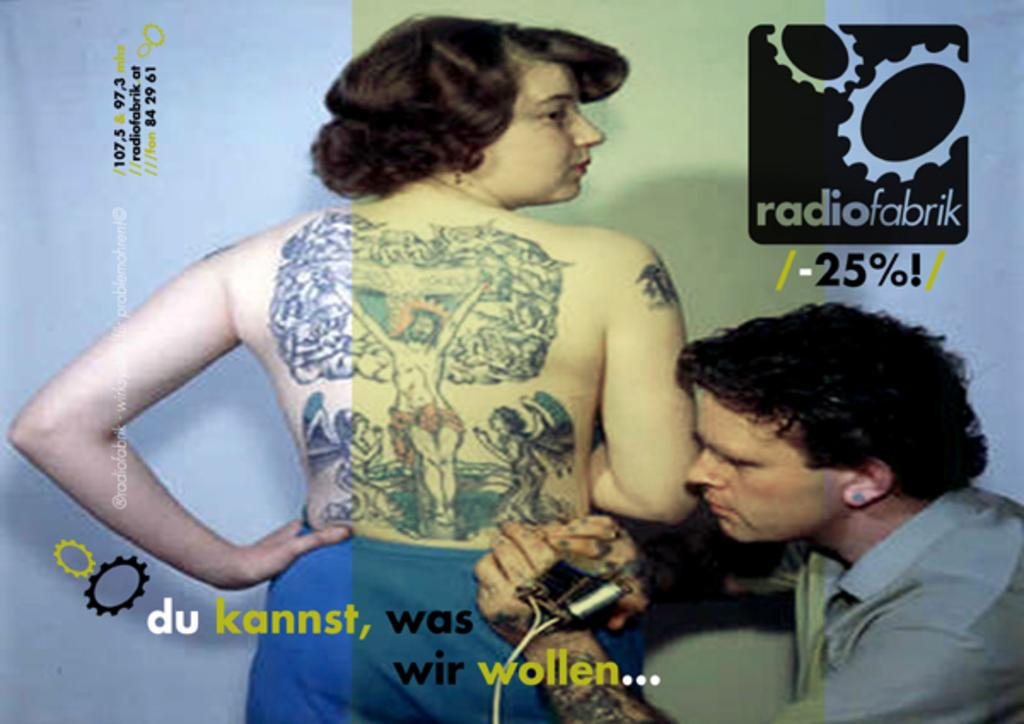How many people are in the image? There are two persons in the image. What is one person doing with their hands? One person is holding a machine. What can be found at the bottom of the image? There is text at the bottom of the image. Where is the logo located in the image? The logo is at the top right corner of the image. What type of turkey can be seen in the image? There is no turkey present in the image. How does the light affect the image? The provided facts do not mention any lighting conditions or effects, so it is impossible to determine how light affects the image. 